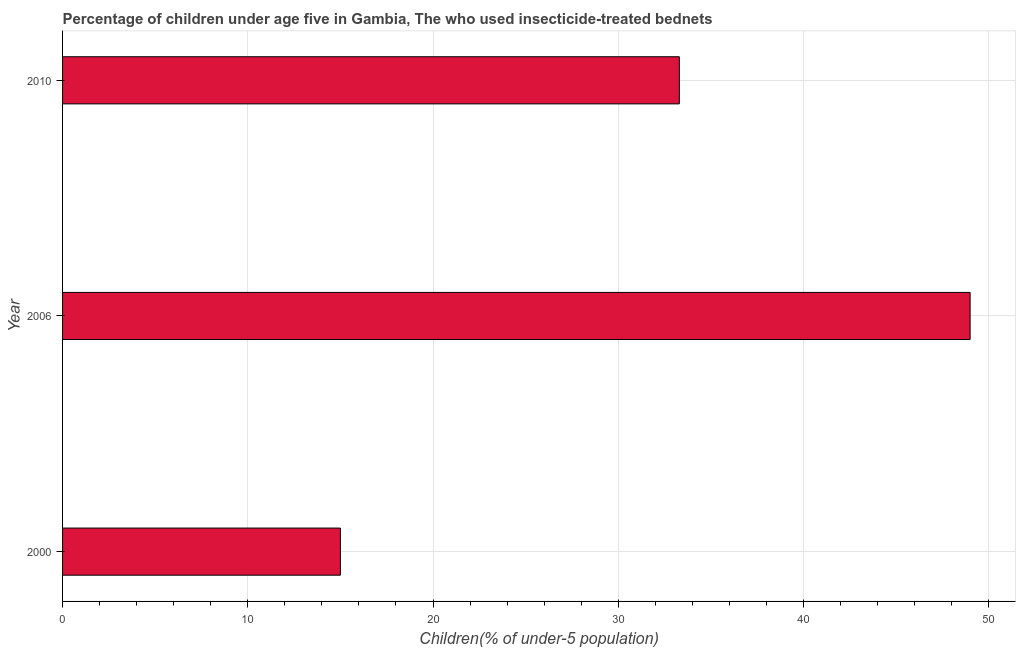Does the graph contain any zero values?
Keep it short and to the point. No. What is the title of the graph?
Keep it short and to the point. Percentage of children under age five in Gambia, The who used insecticide-treated bednets. What is the label or title of the X-axis?
Keep it short and to the point. Children(% of under-5 population). What is the percentage of children who use of insecticide-treated bed nets in 2000?
Offer a very short reply. 15. Across all years, what is the maximum percentage of children who use of insecticide-treated bed nets?
Your response must be concise. 49. In which year was the percentage of children who use of insecticide-treated bed nets minimum?
Your answer should be very brief. 2000. What is the sum of the percentage of children who use of insecticide-treated bed nets?
Provide a short and direct response. 97.3. What is the difference between the percentage of children who use of insecticide-treated bed nets in 2000 and 2006?
Provide a succinct answer. -34. What is the average percentage of children who use of insecticide-treated bed nets per year?
Make the answer very short. 32.43. What is the median percentage of children who use of insecticide-treated bed nets?
Ensure brevity in your answer.  33.3. What is the ratio of the percentage of children who use of insecticide-treated bed nets in 2000 to that in 2010?
Offer a very short reply. 0.45. Is the difference between the percentage of children who use of insecticide-treated bed nets in 2006 and 2010 greater than the difference between any two years?
Provide a short and direct response. No. Is the sum of the percentage of children who use of insecticide-treated bed nets in 2006 and 2010 greater than the maximum percentage of children who use of insecticide-treated bed nets across all years?
Provide a short and direct response. Yes. In how many years, is the percentage of children who use of insecticide-treated bed nets greater than the average percentage of children who use of insecticide-treated bed nets taken over all years?
Make the answer very short. 2. Are all the bars in the graph horizontal?
Keep it short and to the point. Yes. How many years are there in the graph?
Offer a very short reply. 3. What is the Children(% of under-5 population) of 2000?
Make the answer very short. 15. What is the Children(% of under-5 population) in 2010?
Keep it short and to the point. 33.3. What is the difference between the Children(% of under-5 population) in 2000 and 2006?
Offer a terse response. -34. What is the difference between the Children(% of under-5 population) in 2000 and 2010?
Give a very brief answer. -18.3. What is the ratio of the Children(% of under-5 population) in 2000 to that in 2006?
Ensure brevity in your answer.  0.31. What is the ratio of the Children(% of under-5 population) in 2000 to that in 2010?
Provide a succinct answer. 0.45. What is the ratio of the Children(% of under-5 population) in 2006 to that in 2010?
Your response must be concise. 1.47. 